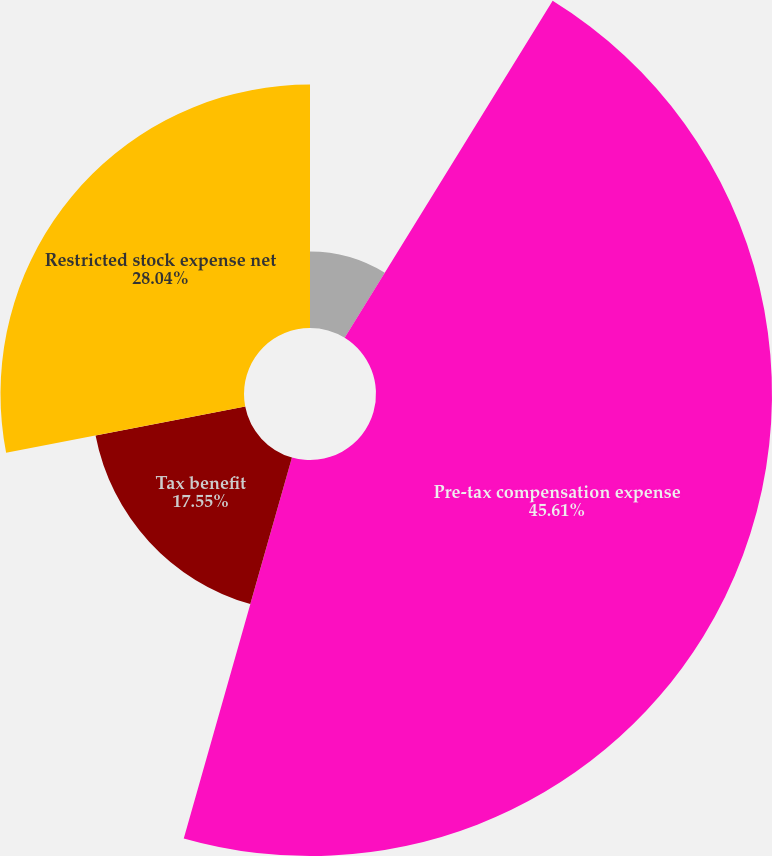<chart> <loc_0><loc_0><loc_500><loc_500><pie_chart><fcel>Years ended December 31<fcel>Pre-tax compensation expense<fcel>Tax benefit<fcel>Restricted stock expense net<nl><fcel>8.8%<fcel>45.6%<fcel>17.55%<fcel>28.04%<nl></chart> 